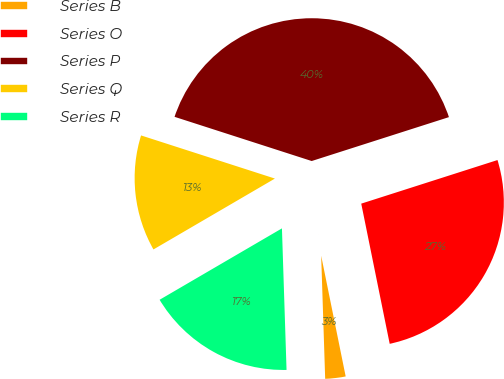<chart> <loc_0><loc_0><loc_500><loc_500><pie_chart><fcel>Series B<fcel>Series O<fcel>Series P<fcel>Series Q<fcel>Series R<nl><fcel>2.67%<fcel>26.74%<fcel>40.11%<fcel>13.37%<fcel>17.11%<nl></chart> 